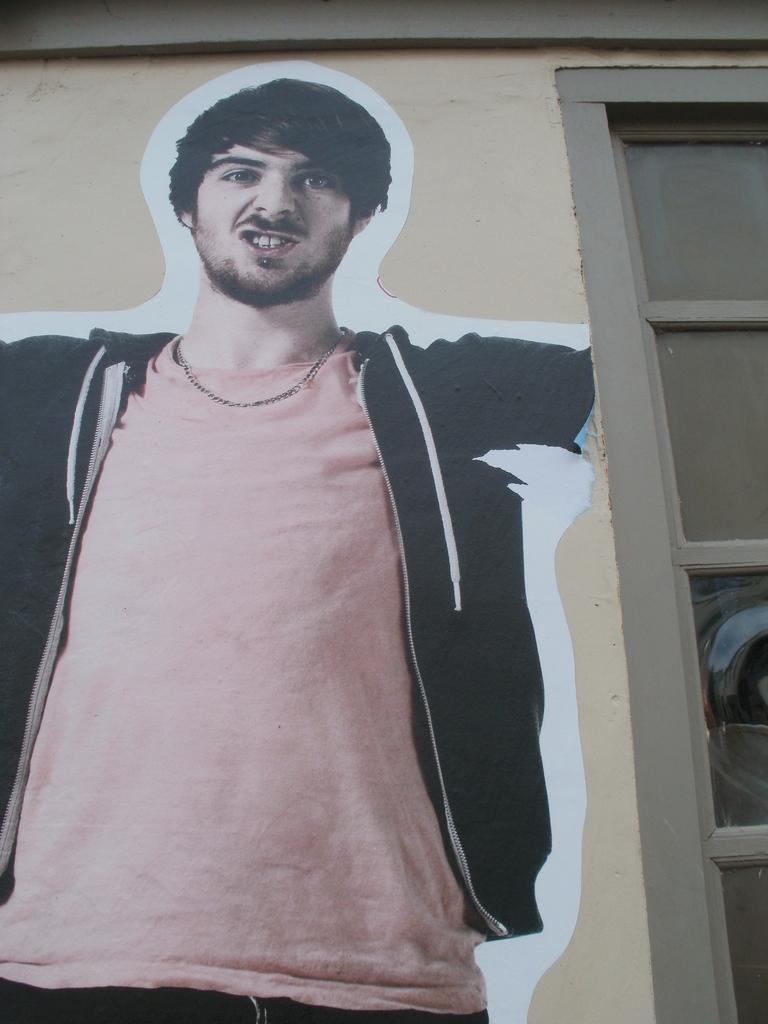What is located in the center of the image? There is a picture on the wall in the center of the image. What can be seen on the right side of the image? There is a window on the right side of the image. What type of exchange is taking place in the image? There is no exchange taking place in the image; it only features a picture on the wall and a window. Are there any pigs present in the image? There are no pigs present in the image. 